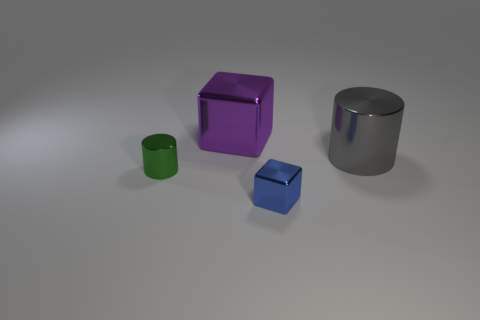Add 4 big blue shiny blocks. How many objects exist? 8 Subtract all small blue cubes. Subtract all cubes. How many objects are left? 1 Add 1 blue shiny objects. How many blue shiny objects are left? 2 Add 1 small blue objects. How many small blue objects exist? 2 Subtract 0 purple cylinders. How many objects are left? 4 